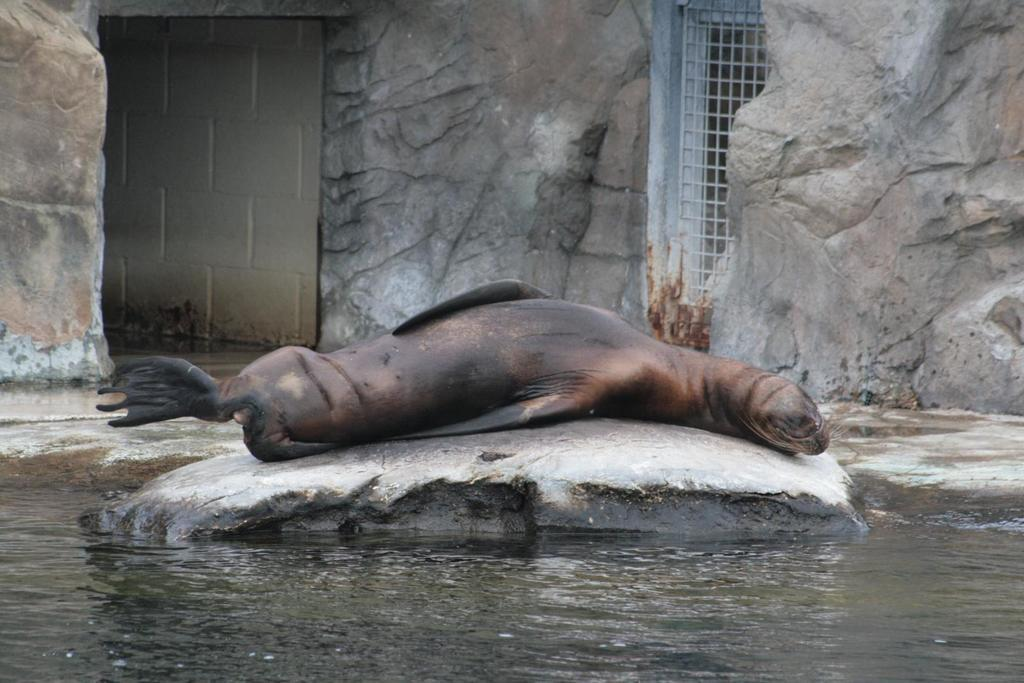What type of animal is on the rock in the image? There is a spinner dolphin on a rock in the image. What is the primary element surrounding the dolphin? Water is visible in the image. What type of structure can be seen in the image? There is a metal grill in the image. What type of natural formation is present in the image? There are rocks in the image. What type of man-made structure is visible in the image? There is a wall in the image. What type of ear is visible on the dolphin in the image? Dolphins do not have external ears, so there is no ear visible on the dolphin in the image. What type of party is taking place in the image? There is no party depicted in the image; it features a spinner dolphin on a rock surrounded by water, a metal grill, rocks, and a wall. 